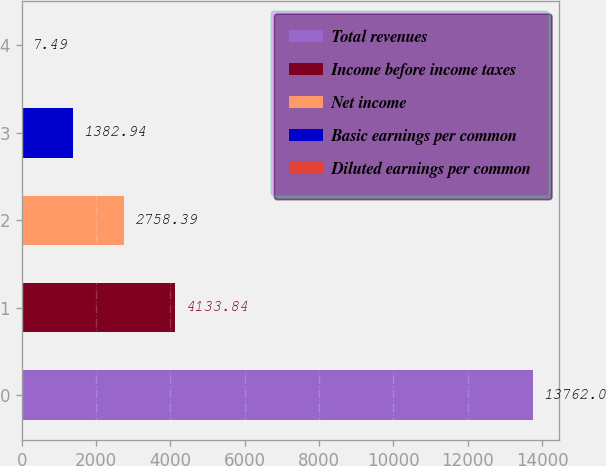Convert chart to OTSL. <chart><loc_0><loc_0><loc_500><loc_500><bar_chart><fcel>Total revenues<fcel>Income before income taxes<fcel>Net income<fcel>Basic earnings per common<fcel>Diluted earnings per common<nl><fcel>13762<fcel>4133.84<fcel>2758.39<fcel>1382.94<fcel>7.49<nl></chart> 